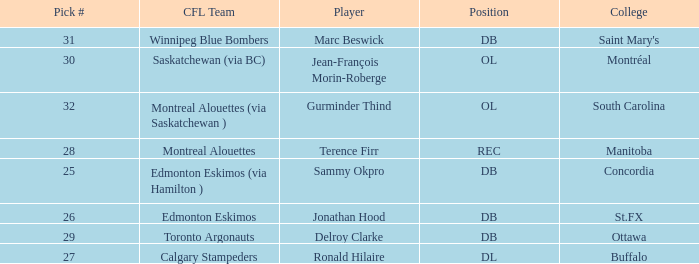Which Pick # has a College of concordia? 25.0. 